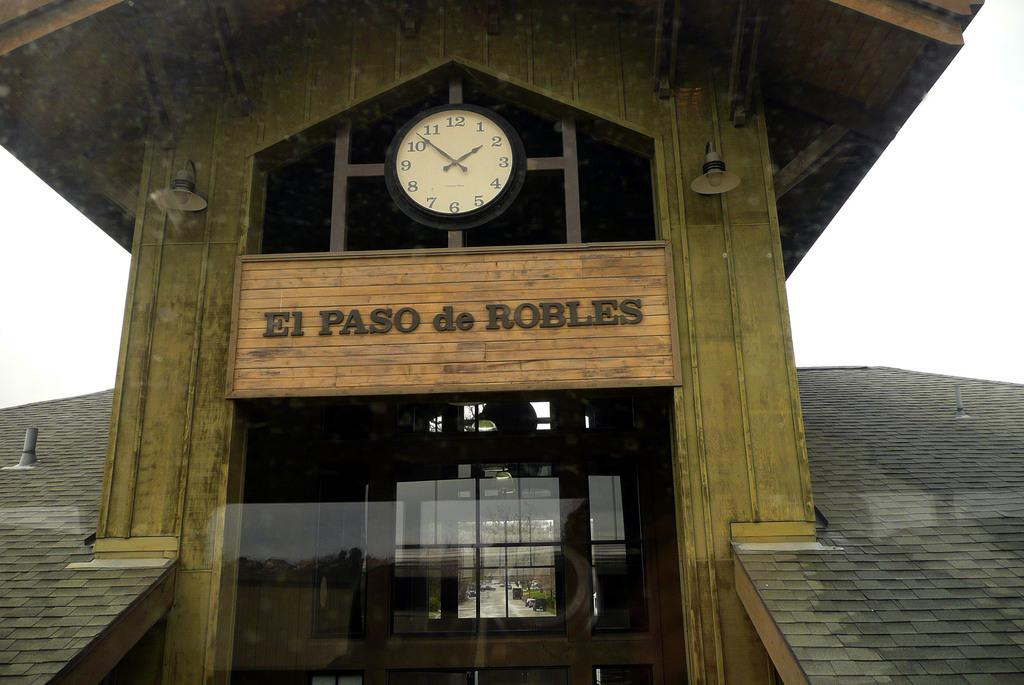Provide a one-sentence caption for the provided image. An old building that is titled EL PASO de ROBLES. 